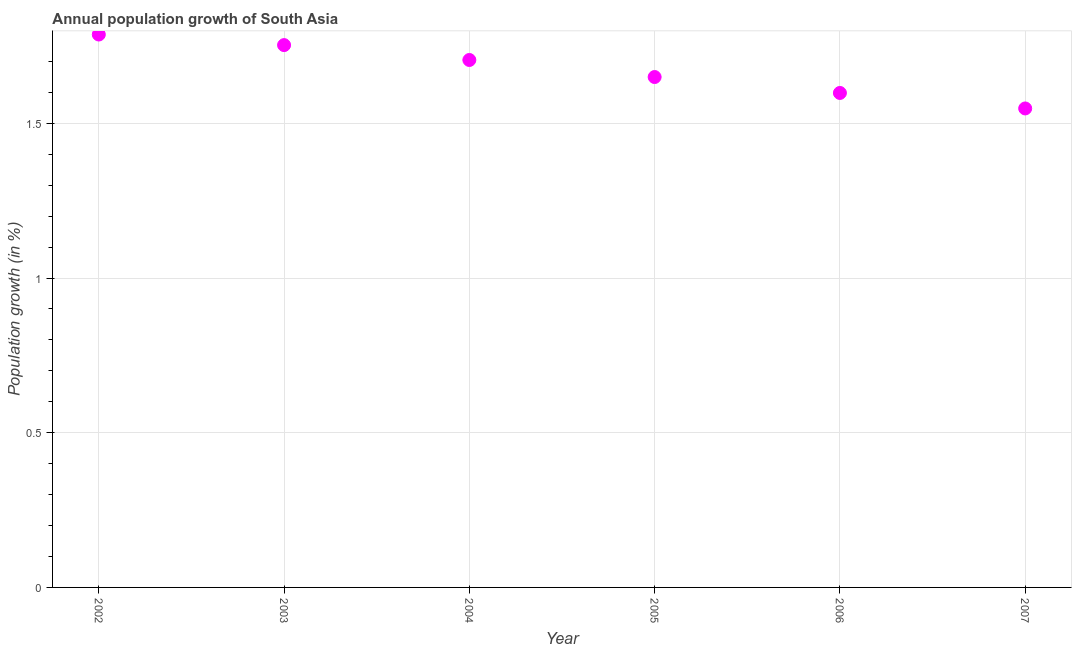What is the population growth in 2003?
Make the answer very short. 1.75. Across all years, what is the maximum population growth?
Give a very brief answer. 1.79. Across all years, what is the minimum population growth?
Give a very brief answer. 1.55. In which year was the population growth maximum?
Keep it short and to the point. 2002. What is the sum of the population growth?
Offer a very short reply. 10.04. What is the difference between the population growth in 2002 and 2004?
Your response must be concise. 0.08. What is the average population growth per year?
Your response must be concise. 1.67. What is the median population growth?
Give a very brief answer. 1.68. What is the ratio of the population growth in 2003 to that in 2006?
Your answer should be very brief. 1.1. Is the difference between the population growth in 2002 and 2007 greater than the difference between any two years?
Provide a short and direct response. Yes. What is the difference between the highest and the second highest population growth?
Your answer should be compact. 0.03. What is the difference between the highest and the lowest population growth?
Provide a short and direct response. 0.24. Does the population growth monotonically increase over the years?
Ensure brevity in your answer.  No. How many dotlines are there?
Provide a short and direct response. 1. How many years are there in the graph?
Your response must be concise. 6. What is the difference between two consecutive major ticks on the Y-axis?
Offer a very short reply. 0.5. What is the title of the graph?
Ensure brevity in your answer.  Annual population growth of South Asia. What is the label or title of the X-axis?
Your answer should be very brief. Year. What is the label or title of the Y-axis?
Provide a short and direct response. Population growth (in %). What is the Population growth (in %) in 2002?
Provide a short and direct response. 1.79. What is the Population growth (in %) in 2003?
Ensure brevity in your answer.  1.75. What is the Population growth (in %) in 2004?
Provide a short and direct response. 1.7. What is the Population growth (in %) in 2005?
Offer a terse response. 1.65. What is the Population growth (in %) in 2006?
Your response must be concise. 1.6. What is the Population growth (in %) in 2007?
Keep it short and to the point. 1.55. What is the difference between the Population growth (in %) in 2002 and 2003?
Your answer should be very brief. 0.03. What is the difference between the Population growth (in %) in 2002 and 2004?
Keep it short and to the point. 0.08. What is the difference between the Population growth (in %) in 2002 and 2005?
Your answer should be very brief. 0.14. What is the difference between the Population growth (in %) in 2002 and 2006?
Ensure brevity in your answer.  0.19. What is the difference between the Population growth (in %) in 2002 and 2007?
Make the answer very short. 0.24. What is the difference between the Population growth (in %) in 2003 and 2004?
Ensure brevity in your answer.  0.05. What is the difference between the Population growth (in %) in 2003 and 2005?
Keep it short and to the point. 0.1. What is the difference between the Population growth (in %) in 2003 and 2006?
Keep it short and to the point. 0.15. What is the difference between the Population growth (in %) in 2003 and 2007?
Your response must be concise. 0.2. What is the difference between the Population growth (in %) in 2004 and 2005?
Make the answer very short. 0.06. What is the difference between the Population growth (in %) in 2004 and 2006?
Give a very brief answer. 0.11. What is the difference between the Population growth (in %) in 2004 and 2007?
Your response must be concise. 0.16. What is the difference between the Population growth (in %) in 2005 and 2006?
Your answer should be compact. 0.05. What is the difference between the Population growth (in %) in 2005 and 2007?
Offer a terse response. 0.1. What is the difference between the Population growth (in %) in 2006 and 2007?
Give a very brief answer. 0.05. What is the ratio of the Population growth (in %) in 2002 to that in 2003?
Make the answer very short. 1.02. What is the ratio of the Population growth (in %) in 2002 to that in 2004?
Keep it short and to the point. 1.05. What is the ratio of the Population growth (in %) in 2002 to that in 2005?
Your response must be concise. 1.08. What is the ratio of the Population growth (in %) in 2002 to that in 2006?
Offer a terse response. 1.12. What is the ratio of the Population growth (in %) in 2002 to that in 2007?
Your answer should be compact. 1.15. What is the ratio of the Population growth (in %) in 2003 to that in 2004?
Your response must be concise. 1.03. What is the ratio of the Population growth (in %) in 2003 to that in 2005?
Offer a terse response. 1.06. What is the ratio of the Population growth (in %) in 2003 to that in 2006?
Your response must be concise. 1.1. What is the ratio of the Population growth (in %) in 2003 to that in 2007?
Your response must be concise. 1.13. What is the ratio of the Population growth (in %) in 2004 to that in 2005?
Keep it short and to the point. 1.03. What is the ratio of the Population growth (in %) in 2004 to that in 2006?
Offer a terse response. 1.07. What is the ratio of the Population growth (in %) in 2004 to that in 2007?
Keep it short and to the point. 1.1. What is the ratio of the Population growth (in %) in 2005 to that in 2006?
Your answer should be very brief. 1.03. What is the ratio of the Population growth (in %) in 2005 to that in 2007?
Ensure brevity in your answer.  1.07. What is the ratio of the Population growth (in %) in 2006 to that in 2007?
Offer a terse response. 1.03. 